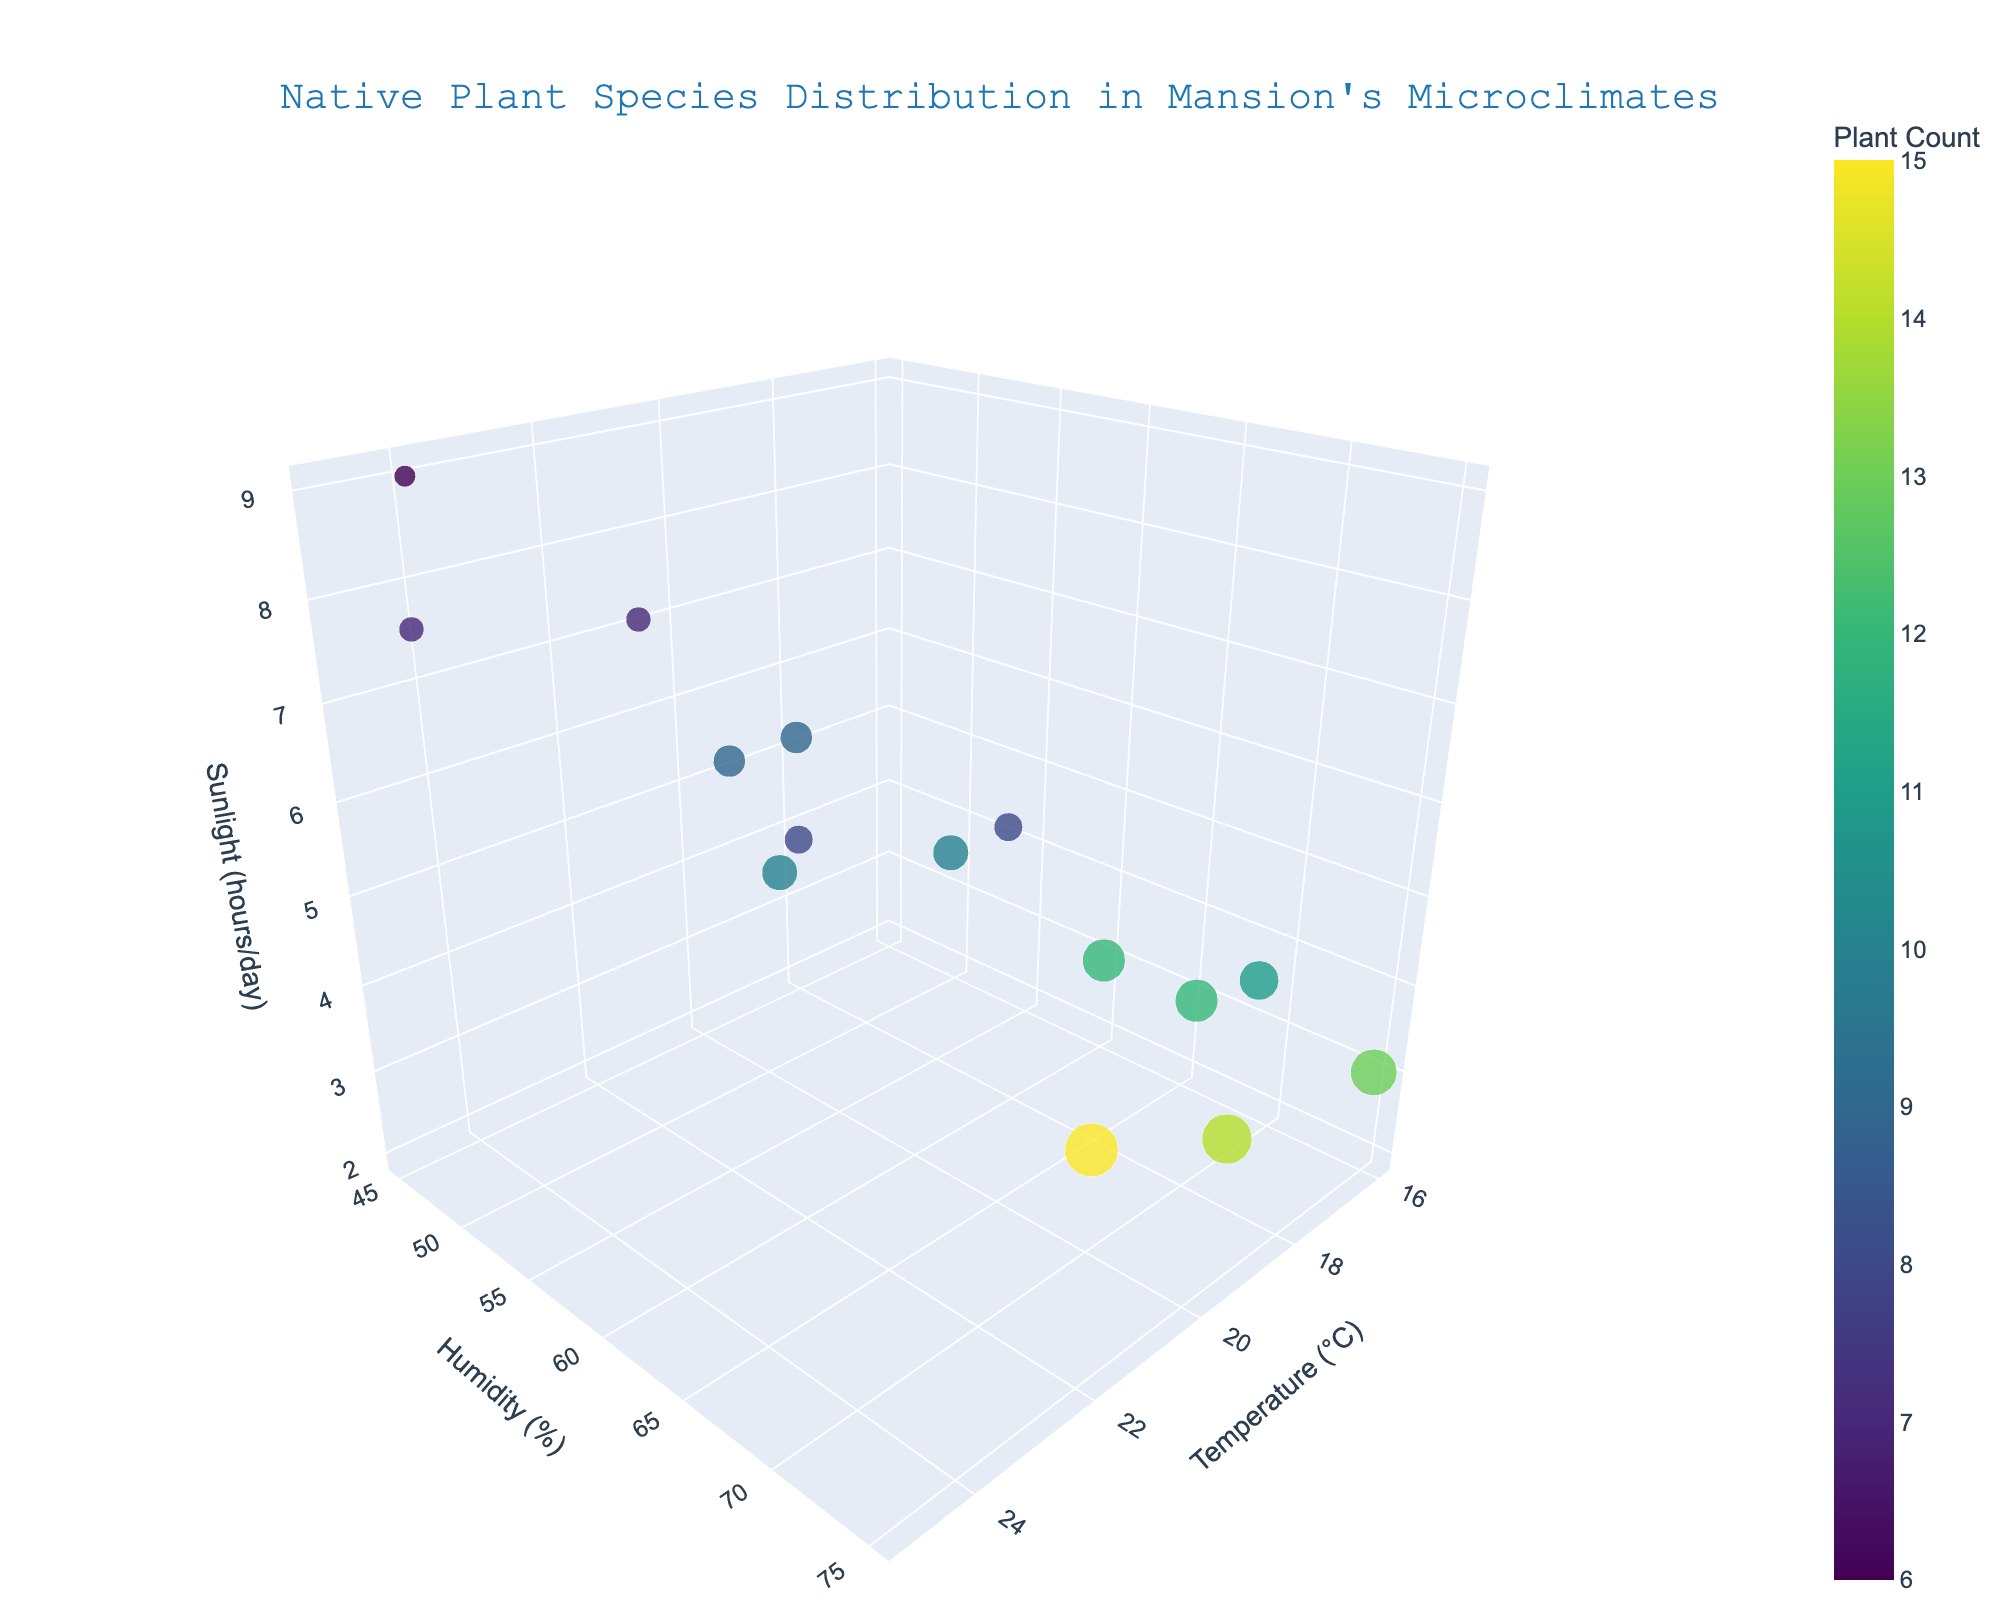Where is the title of this plot located? The title is located at the top center of the plot.
Answer: Top center Which plant species has the highest count of observations? By looking at the size of the markers, the largest marker represents "Virginia Bluebells" with 15 observations.
Answer: Virginia Bluebells What is the sunlight exposure for Cardinal Flower? Hovering over the Cardinal Flower data point shows it has 5 hours of sunlight exposure per day.
Answer: 5 hours Which species are situated at the highest humidity level? Observing the y-axis, American Witch-Hazel and Cardinal Flower are located at the highest humidity level of 75%.
Answer: American Witch-Hazel, Cardinal Flower How do the temperatures of Black-Eyed Susan and New England Aster compare? Comparing the x-axis positions, Black-Eyed Susan is at 24°C, while New England Aster is at 23°C.
Answer: Black-Eyed Susan has a higher temperature than New England Aster How many species are observed in the temperature range between 20°C and 22°C? By checking the x-coordinates, the species observed in the range 20°C to 22°C are Eastern Redbud, Virginia Bluebells, Wild Columbine, Cardinal Flower, Scarlet Bee Balm, and Flowering Dogwood.
Answer: 6 Which species have sunlight exposure between 6 and 8 hours/day? Checking the z-axis positions, Eastern Redbud, New England Aster, Flowering Dogwood, False Indigo, Purple Coneflower, and Scarlet Bee Balm have sunlight exposure between 6 and 8 hours per day.
Answer: Eastern Redbud, New England Aster, Flowering Dogwood, False Indigo, Purple Coneflower, Scarlet Bee Balm Compare the average temperature of Mountain Laurel, Wood Anemone, and Solomon's Seal. The temperatures are 18°C, 18°C, and 17°C respectively. Average is (18 + 18 + 17) / 3 = 17.67°C
Answer: 17.67°C Which species has the most sunlight exposure at the highest temperature? Observing the z-axis (sunlight) and x-axis (temperature), the highest temperature with the most sunlight is Black-Eyed Susan at 24°C with 9 hours per day.
Answer: Black-Eyed Susan 